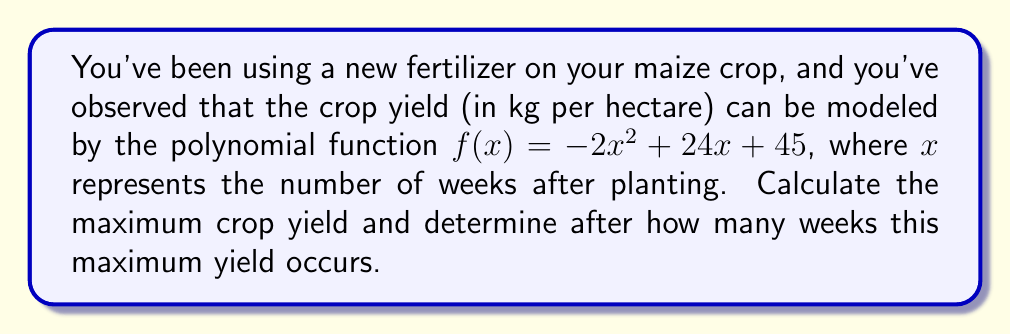Solve this math problem. To solve this problem, we'll follow these steps:

1) The maximum yield occurs at the vertex of the parabola. For a quadratic function in the form $f(x) = ax^2 + bx + c$, the x-coordinate of the vertex is given by $x = -\frac{b}{2a}$.

2) In our function $f(x) = -2x^2 + 24x + 45$, we have:
   $a = -2$
   $b = 24$
   $c = 45$

3) Let's calculate the x-coordinate of the vertex:

   $x = -\frac{b}{2a} = -\frac{24}{2(-2)} = -\frac{24}{-4} = 6$

4) This means the maximum yield occurs 6 weeks after planting.

5) To find the maximum yield, we need to calculate $f(6)$:

   $f(6) = -2(6)^2 + 24(6) + 45$
   $= -2(36) + 144 + 45$
   $= -72 + 144 + 45$
   $= 117$

Therefore, the maximum yield is 117 kg per hectare.
Answer: Maximum yield: 117 kg/ha, occurs 6 weeks after planting 